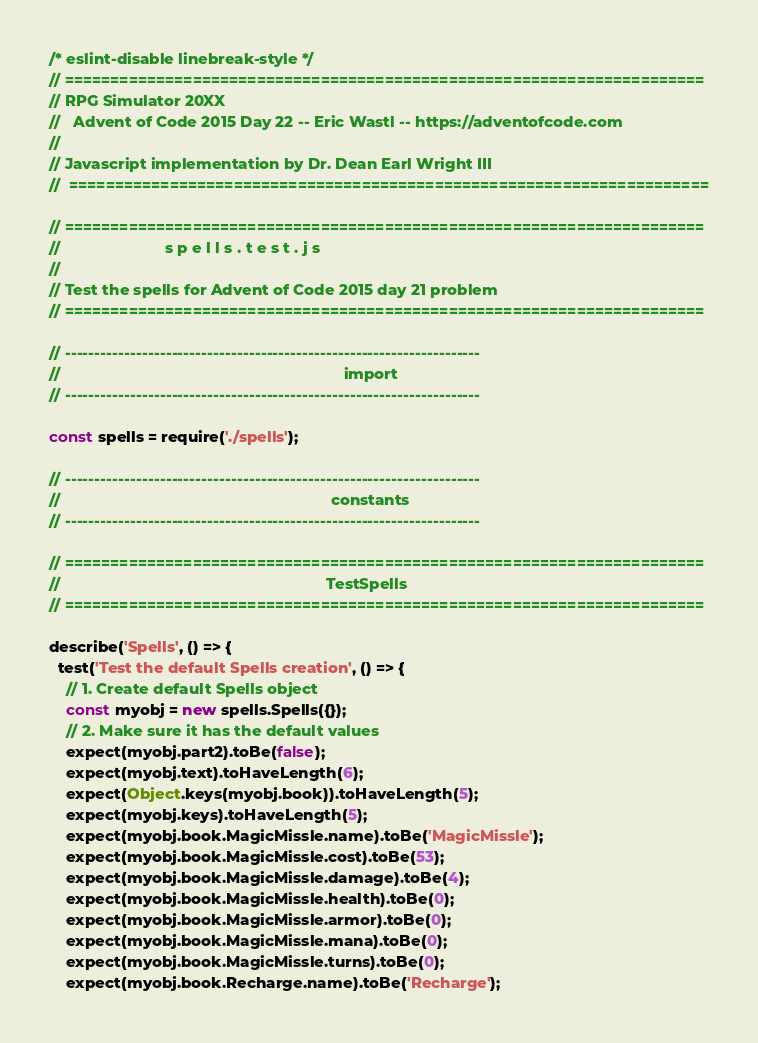<code> <loc_0><loc_0><loc_500><loc_500><_JavaScript_>/* eslint-disable linebreak-style */
// ======================================================================
// RPG Simulator 20XX
//   Advent of Code 2015 Day 22 -- Eric Wastl -- https://adventofcode.com
//
// Javascript implementation by Dr. Dean Earl Wright III
//  ======================================================================

// ======================================================================
//                        s p e l l s . t e s t . j s
//
// Test the spells for Advent of Code 2015 day 21 problem
// ======================================================================

// ----------------------------------------------------------------------
//                                                                 import
// ----------------------------------------------------------------------

const spells = require('./spells');

// ----------------------------------------------------------------------
//                                                              constants
// ----------------------------------------------------------------------

// ======================================================================
//                                                             TestSpells
// ======================================================================

describe('Spells', () => {
  test('Test the default Spells creation', () => {
    // 1. Create default Spells object
    const myobj = new spells.Spells({});
    // 2. Make sure it has the default values
    expect(myobj.part2).toBe(false);
    expect(myobj.text).toHaveLength(6);
    expect(Object.keys(myobj.book)).toHaveLength(5);
    expect(myobj.keys).toHaveLength(5);
    expect(myobj.book.MagicMissle.name).toBe('MagicMissle');
    expect(myobj.book.MagicMissle.cost).toBe(53);
    expect(myobj.book.MagicMissle.damage).toBe(4);
    expect(myobj.book.MagicMissle.health).toBe(0);
    expect(myobj.book.MagicMissle.armor).toBe(0);
    expect(myobj.book.MagicMissle.mana).toBe(0);
    expect(myobj.book.MagicMissle.turns).toBe(0);
    expect(myobj.book.Recharge.name).toBe('Recharge');</code> 